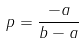<formula> <loc_0><loc_0><loc_500><loc_500>p = \frac { - a } { b - a }</formula> 